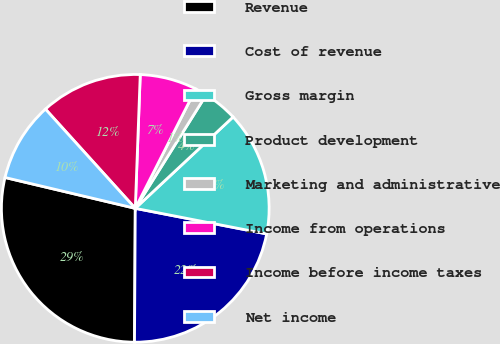<chart> <loc_0><loc_0><loc_500><loc_500><pie_chart><fcel>Revenue<fcel>Cost of revenue<fcel>Gross margin<fcel>Product development<fcel>Marketing and administrative<fcel>Income from operations<fcel>Income before income taxes<fcel>Net income<nl><fcel>28.61%<fcel>22.03%<fcel>15.02%<fcel>4.15%<fcel>1.43%<fcel>6.87%<fcel>12.3%<fcel>9.59%<nl></chart> 